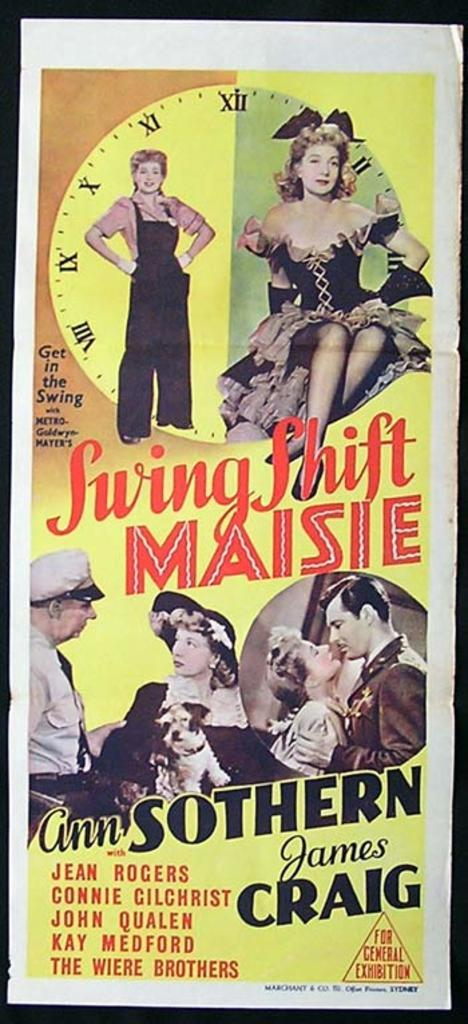<image>
Offer a succinct explanation of the picture presented. A movie poster for Swing Shift Maisie features photos of Ann Sothern and James Craig. 